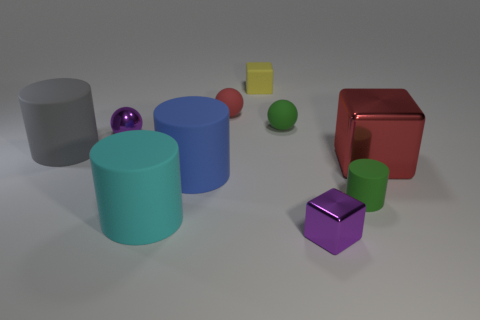Subtract 1 cylinders. How many cylinders are left? 3 Subtract all cubes. How many objects are left? 7 Add 9 large cyan matte cylinders. How many large cyan matte cylinders are left? 10 Add 3 blue matte things. How many blue matte things exist? 4 Subtract 1 red blocks. How many objects are left? 9 Subtract all tiny matte cylinders. Subtract all large cyan cylinders. How many objects are left? 8 